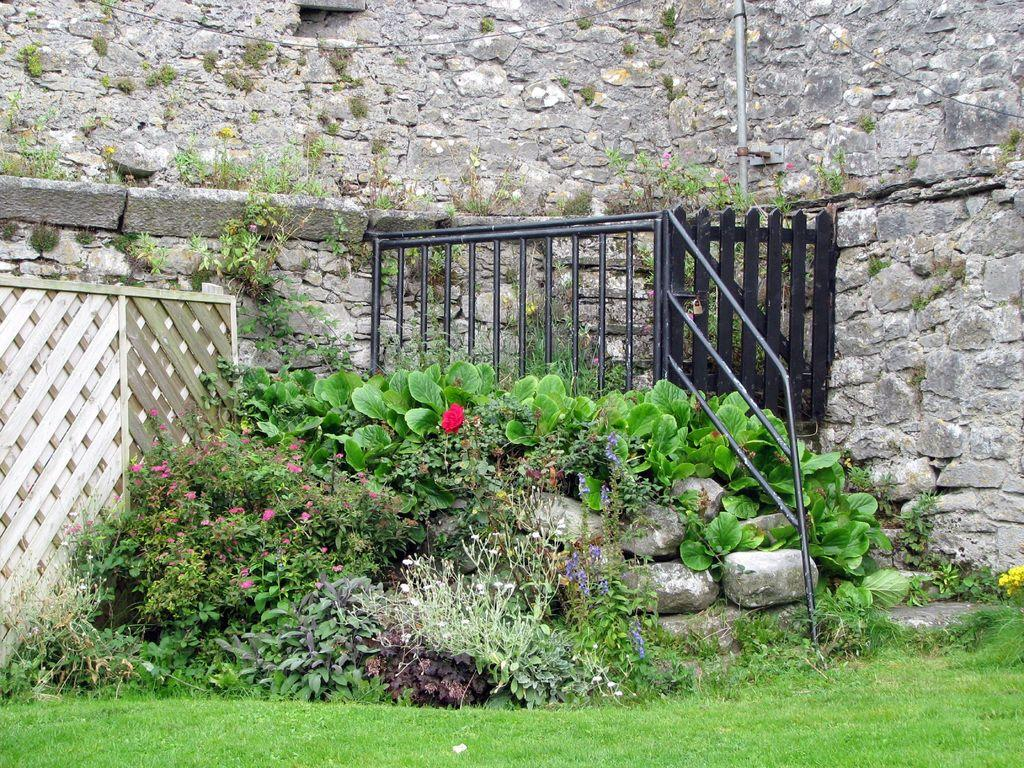What type of vegetation can be seen in the image? There are plants in the image. What material is the fence in the image made of? The fence in the image is made of metal. Is there an entrance in the fence? Yes, there is a gate in the image. What is covering the ground in the image? Grass is visible on the ground in the image. What type of structure is present in the image? There is a building in the image. What type of wood can be seen in the image? There is no wood present in the image. 